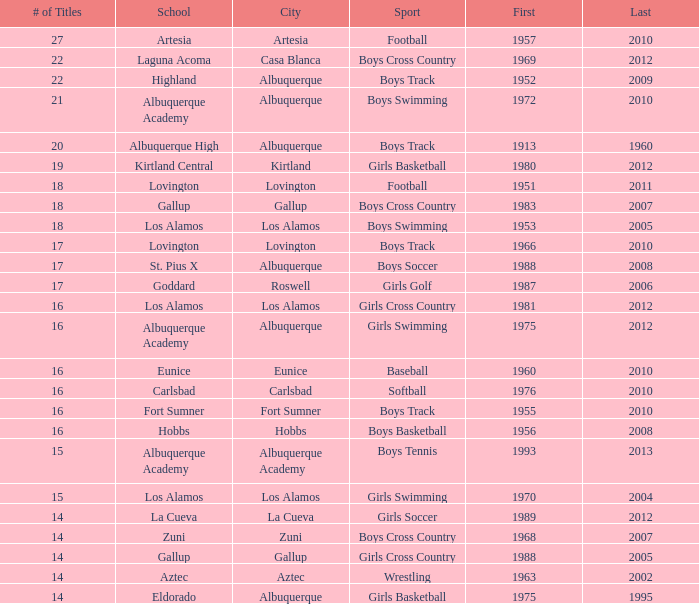In albuquerque, what is the maximum ranking for the boys' swimming team? 3.0. 